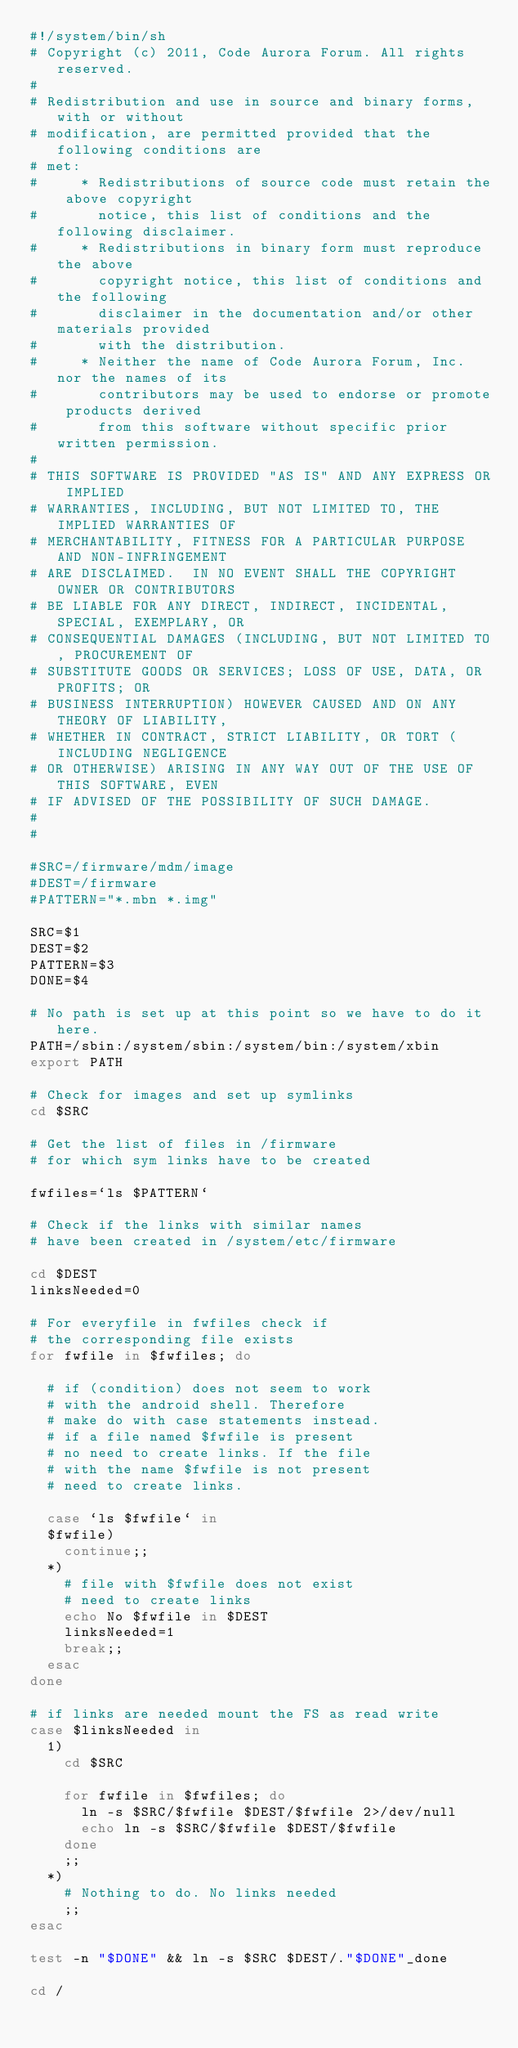<code> <loc_0><loc_0><loc_500><loc_500><_Bash_>#!/system/bin/sh
# Copyright (c) 2011, Code Aurora Forum. All rights reserved.
#
# Redistribution and use in source and binary forms, with or without
# modification, are permitted provided that the following conditions are
# met:
#     * Redistributions of source code must retain the above copyright
#       notice, this list of conditions and the following disclaimer.
#     * Redistributions in binary form must reproduce the above
#       copyright notice, this list of conditions and the following
#       disclaimer in the documentation and/or other materials provided
#       with the distribution.
#     * Neither the name of Code Aurora Forum, Inc. nor the names of its
#       contributors may be used to endorse or promote products derived
#       from this software without specific prior written permission.
#
# THIS SOFTWARE IS PROVIDED "AS IS" AND ANY EXPRESS OR IMPLIED
# WARRANTIES, INCLUDING, BUT NOT LIMITED TO, THE IMPLIED WARRANTIES OF
# MERCHANTABILITY, FITNESS FOR A PARTICULAR PURPOSE AND NON-INFRINGEMENT
# ARE DISCLAIMED.  IN NO EVENT SHALL THE COPYRIGHT OWNER OR CONTRIBUTORS
# BE LIABLE FOR ANY DIRECT, INDIRECT, INCIDENTAL, SPECIAL, EXEMPLARY, OR
# CONSEQUENTIAL DAMAGES (INCLUDING, BUT NOT LIMITED TO, PROCUREMENT OF
# SUBSTITUTE GOODS OR SERVICES; LOSS OF USE, DATA, OR PROFITS; OR
# BUSINESS INTERRUPTION) HOWEVER CAUSED AND ON ANY THEORY OF LIABILITY,
# WHETHER IN CONTRACT, STRICT LIABILITY, OR TORT (INCLUDING NEGLIGENCE
# OR OTHERWISE) ARISING IN ANY WAY OUT OF THE USE OF THIS SOFTWARE, EVEN
# IF ADVISED OF THE POSSIBILITY OF SUCH DAMAGE.
#
#

#SRC=/firmware/mdm/image
#DEST=/firmware
#PATTERN="*.mbn *.img"

SRC=$1
DEST=$2
PATTERN=$3
DONE=$4

# No path is set up at this point so we have to do it here.
PATH=/sbin:/system/sbin:/system/bin:/system/xbin
export PATH

# Check for images and set up symlinks
cd $SRC

# Get the list of files in /firmware
# for which sym links have to be created

fwfiles=`ls $PATTERN`

# Check if the links with similar names
# have been created in /system/etc/firmware

cd $DEST
linksNeeded=0

# For everyfile in fwfiles check if
# the corresponding file exists
for fwfile in $fwfiles; do

	# if (condition) does not seem to work
	# with the android shell. Therefore
	# make do with case statements instead.
	# if a file named $fwfile is present
	# no need to create links. If the file
	# with the name $fwfile is not present
	# need to create links.

	case `ls $fwfile` in
	$fwfile)
		continue;;
	*)
		# file with $fwfile does not exist
		# need to create links
		echo No $fwfile in $DEST
		linksNeeded=1
		break;;
	esac
done

# if links are needed mount the FS as read write
case $linksNeeded in
	1)
		cd $SRC

		for fwfile in $fwfiles; do
			ln -s $SRC/$fwfile $DEST/$fwfile 2>/dev/null
			echo ln -s $SRC/$fwfile $DEST/$fwfile
		done
		;;
	*)
		# Nothing to do. No links needed
		;;
esac

test -n "$DONE" && ln -s $SRC $DEST/."$DONE"_done

cd /
</code> 